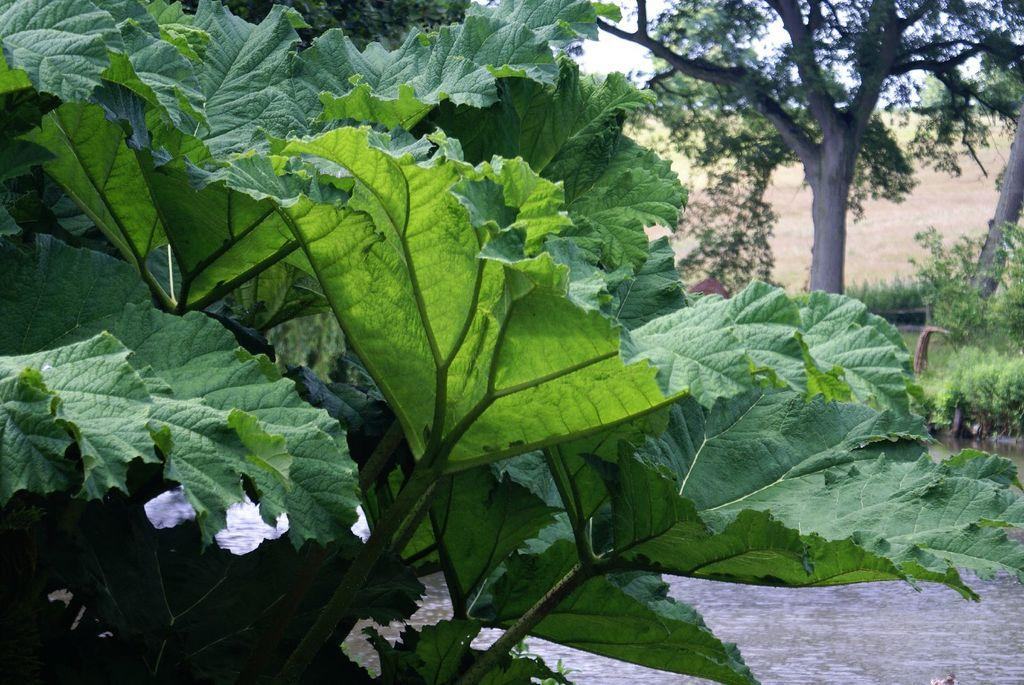What type of vegetation can be seen in the image? There are leaves and trees visible in the image. What natural element is also present in the image? There is water visible in the image. What type of hat is floating on the sea in the image? There is no sea or hat present in the image; it features leaves, trees, and water. 